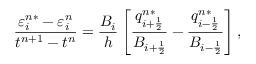<formula> <loc_0><loc_0><loc_500><loc_500>\frac { \varepsilon _ { i } ^ { n * } - \varepsilon _ { i } ^ { n } } { t ^ { n + 1 } - t ^ { n } } = \frac { B _ { i } } { h } \left [ \frac { q _ { i + \frac { 1 } { 2 } } ^ { n * } } { B _ { i + \frac { 1 } { 2 } } } - \frac { q _ { i - \frac { 1 } { 2 } } ^ { n * } } { B _ { i - \frac { 1 } { 2 } } } \right ] ,</formula> 